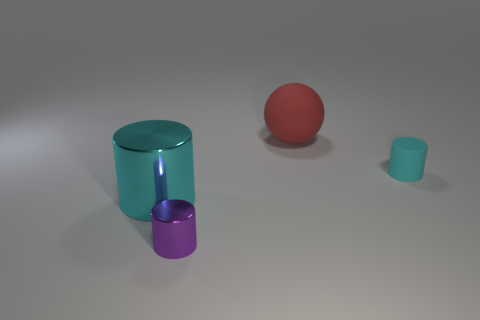Subtract all yellow balls. Subtract all cyan cylinders. How many balls are left? 1 Add 3 gray matte spheres. How many objects exist? 7 Subtract all cylinders. How many objects are left? 1 Subtract 0 green blocks. How many objects are left? 4 Subtract all purple objects. Subtract all big cyan things. How many objects are left? 2 Add 4 large balls. How many large balls are left? 5 Add 3 large cyan cylinders. How many large cyan cylinders exist? 4 